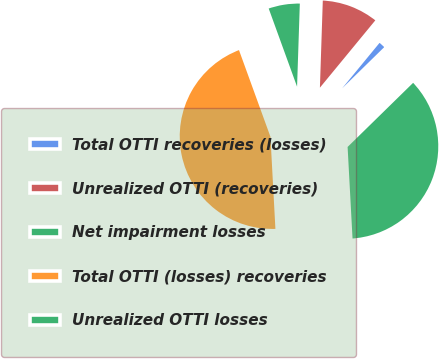Convert chart. <chart><loc_0><loc_0><loc_500><loc_500><pie_chart><fcel>Total OTTI recoveries (losses)<fcel>Unrealized OTTI (recoveries)<fcel>Net impairment losses<fcel>Total OTTI (losses) recoveries<fcel>Unrealized OTTI losses<nl><fcel>1.71%<fcel>10.43%<fcel>6.07%<fcel>45.31%<fcel>36.47%<nl></chart> 